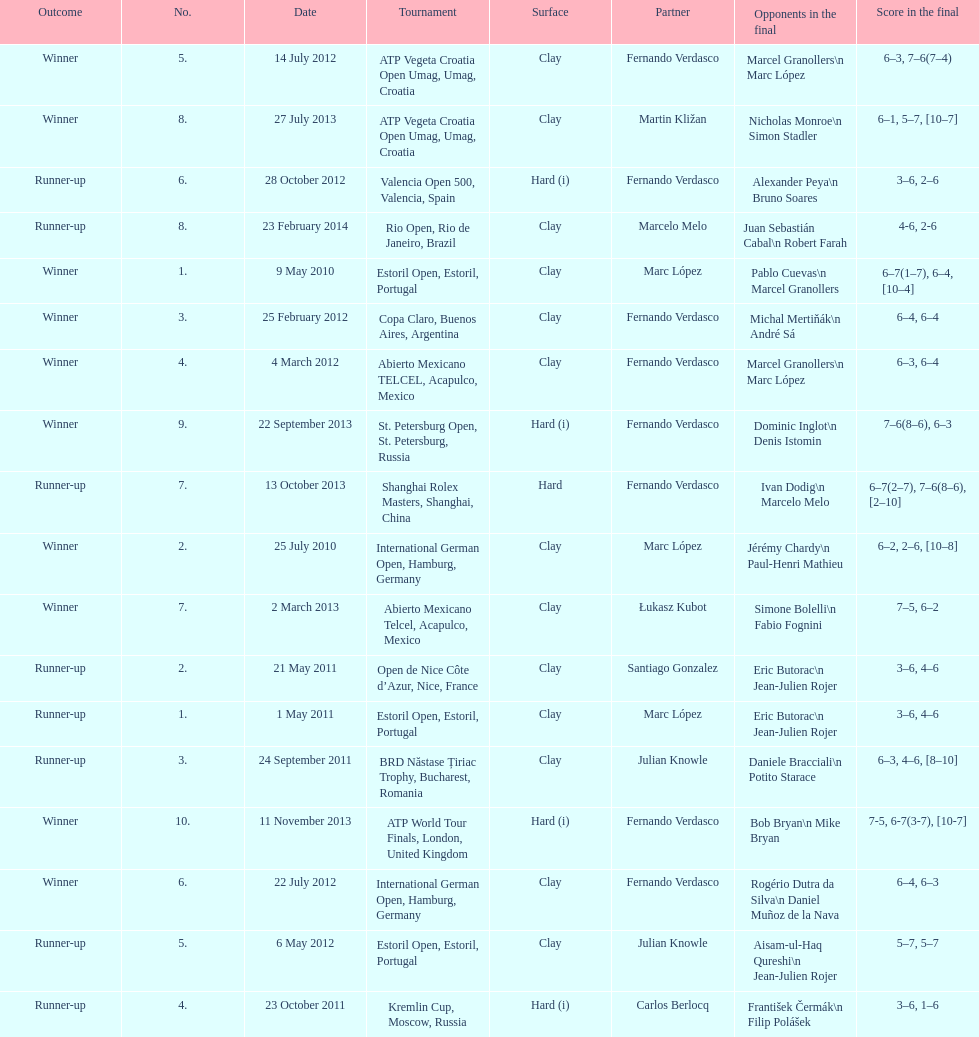What is the number of times a hard surface was used? 5. Parse the table in full. {'header': ['Outcome', 'No.', 'Date', 'Tournament', 'Surface', 'Partner', 'Opponents in the final', 'Score in the final'], 'rows': [['Winner', '5.', '14 July 2012', 'ATP Vegeta Croatia Open Umag, Umag, Croatia', 'Clay', 'Fernando Verdasco', 'Marcel Granollers\\n Marc López', '6–3, 7–6(7–4)'], ['Winner', '8.', '27 July 2013', 'ATP Vegeta Croatia Open Umag, Umag, Croatia', 'Clay', 'Martin Kližan', 'Nicholas Monroe\\n Simon Stadler', '6–1, 5–7, [10–7]'], ['Runner-up', '6.', '28 October 2012', 'Valencia Open 500, Valencia, Spain', 'Hard (i)', 'Fernando Verdasco', 'Alexander Peya\\n Bruno Soares', '3–6, 2–6'], ['Runner-up', '8.', '23 February 2014', 'Rio Open, Rio de Janeiro, Brazil', 'Clay', 'Marcelo Melo', 'Juan Sebastián Cabal\\n Robert Farah', '4-6, 2-6'], ['Winner', '1.', '9 May 2010', 'Estoril Open, Estoril, Portugal', 'Clay', 'Marc López', 'Pablo Cuevas\\n Marcel Granollers', '6–7(1–7), 6–4, [10–4]'], ['Winner', '3.', '25 February 2012', 'Copa Claro, Buenos Aires, Argentina', 'Clay', 'Fernando Verdasco', 'Michal Mertiňák\\n André Sá', '6–4, 6–4'], ['Winner', '4.', '4 March 2012', 'Abierto Mexicano TELCEL, Acapulco, Mexico', 'Clay', 'Fernando Verdasco', 'Marcel Granollers\\n Marc López', '6–3, 6–4'], ['Winner', '9.', '22 September 2013', 'St. Petersburg Open, St. Petersburg, Russia', 'Hard (i)', 'Fernando Verdasco', 'Dominic Inglot\\n Denis Istomin', '7–6(8–6), 6–3'], ['Runner-up', '7.', '13 October 2013', 'Shanghai Rolex Masters, Shanghai, China', 'Hard', 'Fernando Verdasco', 'Ivan Dodig\\n Marcelo Melo', '6–7(2–7), 7–6(8–6), [2–10]'], ['Winner', '2.', '25 July 2010', 'International German Open, Hamburg, Germany', 'Clay', 'Marc López', 'Jérémy Chardy\\n Paul-Henri Mathieu', '6–2, 2–6, [10–8]'], ['Winner', '7.', '2 March 2013', 'Abierto Mexicano Telcel, Acapulco, Mexico', 'Clay', 'Łukasz Kubot', 'Simone Bolelli\\n Fabio Fognini', '7–5, 6–2'], ['Runner-up', '2.', '21 May 2011', 'Open de Nice Côte d’Azur, Nice, France', 'Clay', 'Santiago Gonzalez', 'Eric Butorac\\n Jean-Julien Rojer', '3–6, 4–6'], ['Runner-up', '1.', '1 May 2011', 'Estoril Open, Estoril, Portugal', 'Clay', 'Marc López', 'Eric Butorac\\n Jean-Julien Rojer', '3–6, 4–6'], ['Runner-up', '3.', '24 September 2011', 'BRD Năstase Țiriac Trophy, Bucharest, Romania', 'Clay', 'Julian Knowle', 'Daniele Bracciali\\n Potito Starace', '6–3, 4–6, [8–10]'], ['Winner', '10.', '11 November 2013', 'ATP World Tour Finals, London, United Kingdom', 'Hard (i)', 'Fernando Verdasco', 'Bob Bryan\\n Mike Bryan', '7-5, 6-7(3-7), [10-7]'], ['Winner', '6.', '22 July 2012', 'International German Open, Hamburg, Germany', 'Clay', 'Fernando Verdasco', 'Rogério Dutra da Silva\\n Daniel Muñoz de la Nava', '6–4, 6–3'], ['Runner-up', '5.', '6 May 2012', 'Estoril Open, Estoril, Portugal', 'Clay', 'Julian Knowle', 'Aisam-ul-Haq Qureshi\\n Jean-Julien Rojer', '5–7, 5–7'], ['Runner-up', '4.', '23 October 2011', 'Kremlin Cup, Moscow, Russia', 'Hard (i)', 'Carlos Berlocq', 'František Čermák\\n Filip Polášek', '3–6, 1–6']]} 